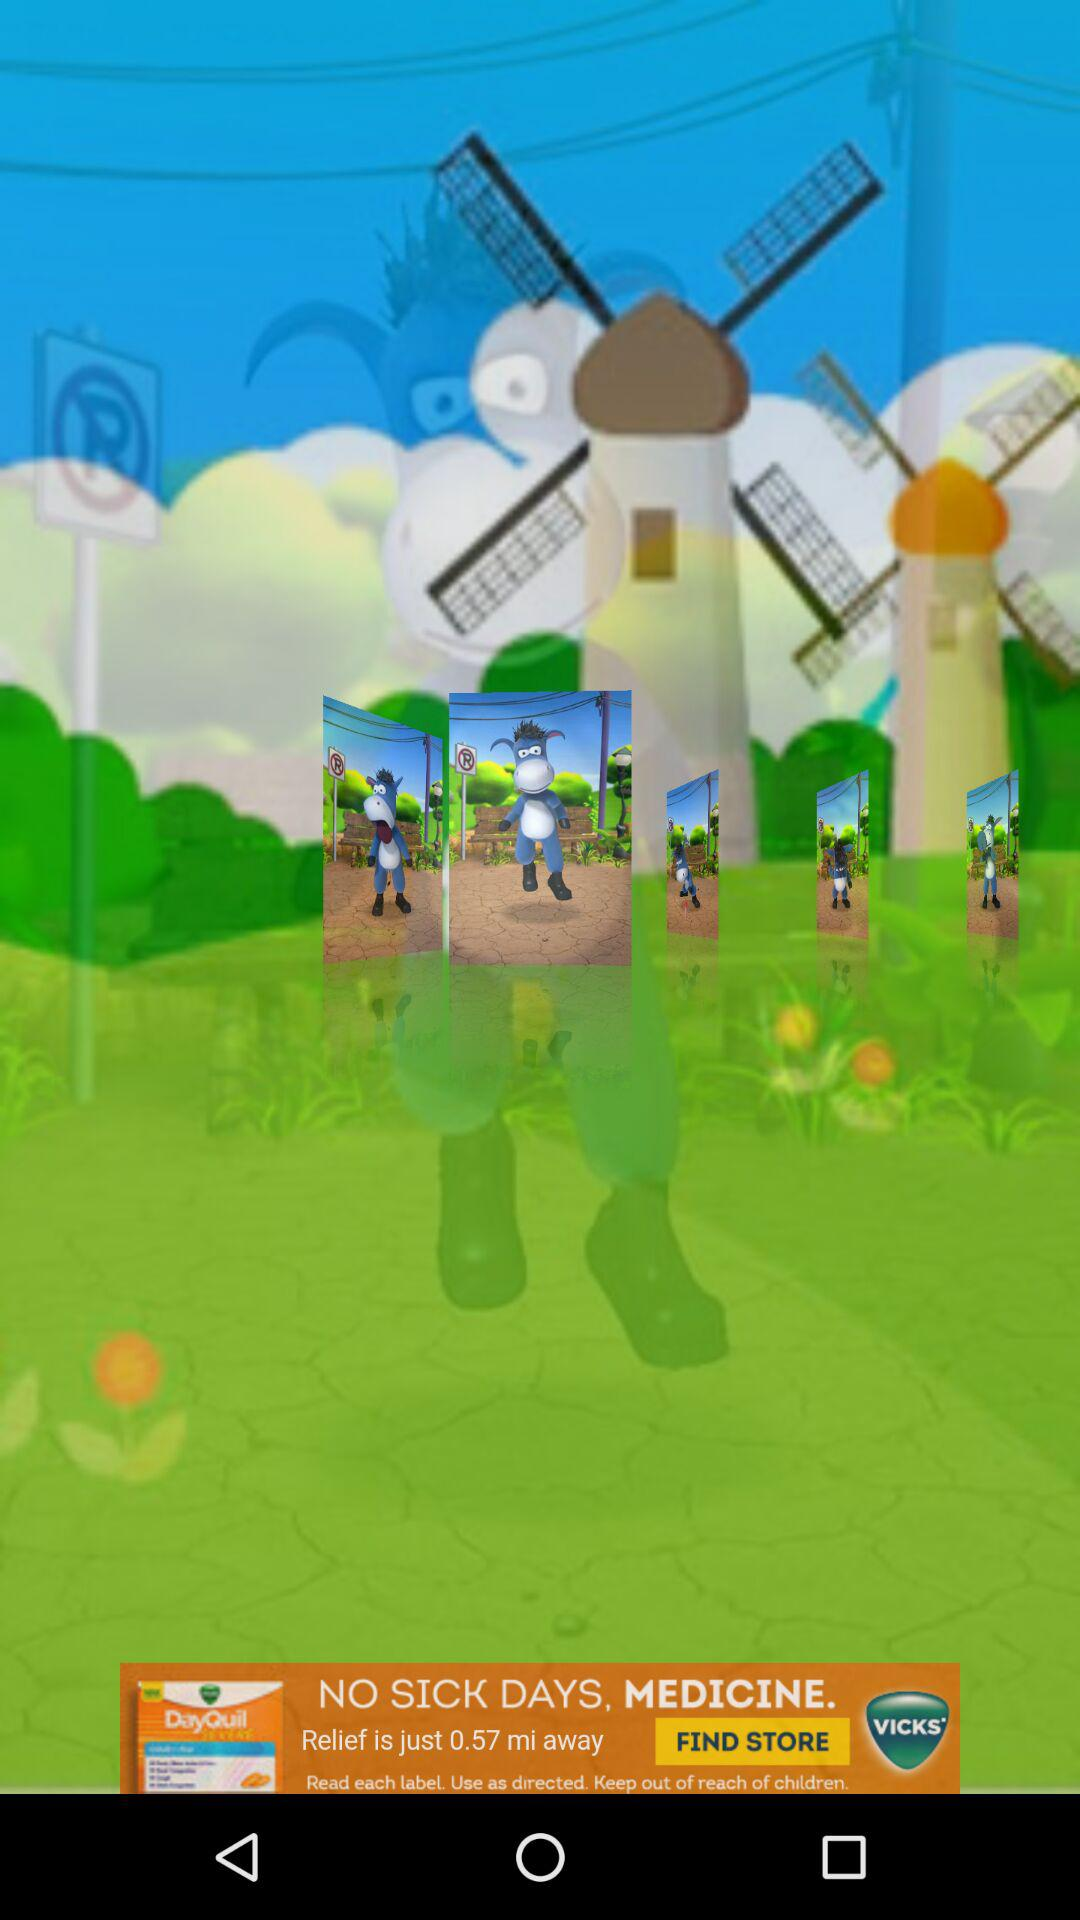How many pictures are shown of the sheep?
Answer the question using a single word or phrase. 5 